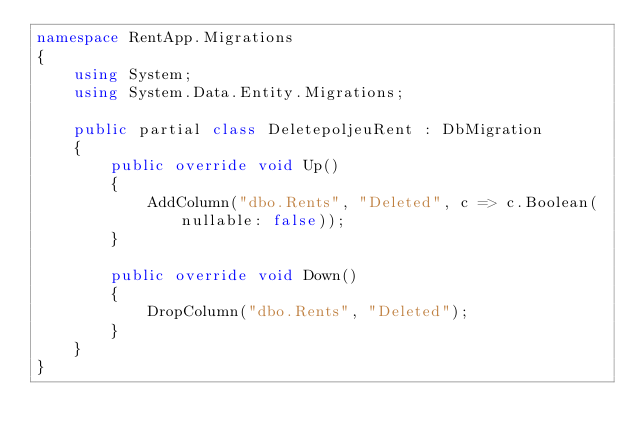<code> <loc_0><loc_0><loc_500><loc_500><_C#_>namespace RentApp.Migrations
{
    using System;
    using System.Data.Entity.Migrations;
    
    public partial class DeletepoljeuRent : DbMigration
    {
        public override void Up()
        {
            AddColumn("dbo.Rents", "Deleted", c => c.Boolean(nullable: false));
        }
        
        public override void Down()
        {
            DropColumn("dbo.Rents", "Deleted");
        }
    }
}
</code> 